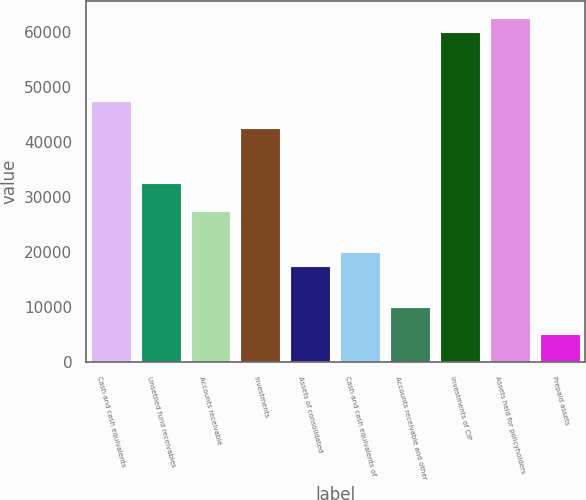Convert chart to OTSL. <chart><loc_0><loc_0><loc_500><loc_500><bar_chart><fcel>Cash and cash equivalents<fcel>Unsettled fund receivables<fcel>Accounts receivable<fcel>Investments<fcel>Assets of consolidated<fcel>Cash and cash equivalents of<fcel>Accounts receivable and other<fcel>Investments of CIP<fcel>Assets held for policyholders<fcel>Prepaid assets<nl><fcel>47550.8<fcel>32565.7<fcel>27570.7<fcel>42555.8<fcel>17580.7<fcel>20078.2<fcel>10088.1<fcel>60038.3<fcel>62535.8<fcel>5093.12<nl></chart> 